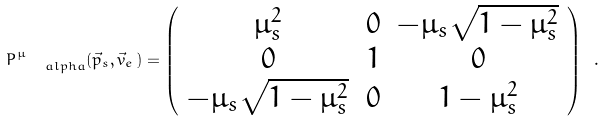Convert formula to latex. <formula><loc_0><loc_0><loc_500><loc_500>P ^ { \mu } _ { \quad a l p h a } ( \vec { p } _ { s } , \vec { v } _ { e } \, ) = \left ( \begin{array} { c c c } \mu _ { s } ^ { 2 } & 0 & - \mu _ { s } \sqrt { 1 - \mu _ { s } ^ { 2 } } \\ 0 & 1 & 0 \\ - \mu _ { s } \sqrt { 1 - \mu _ { s } ^ { 2 } } & 0 & 1 - \mu _ { s } ^ { 2 } \end{array} \right ) \ .</formula> 